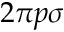<formula> <loc_0><loc_0><loc_500><loc_500>2 \pi p \sigma</formula> 